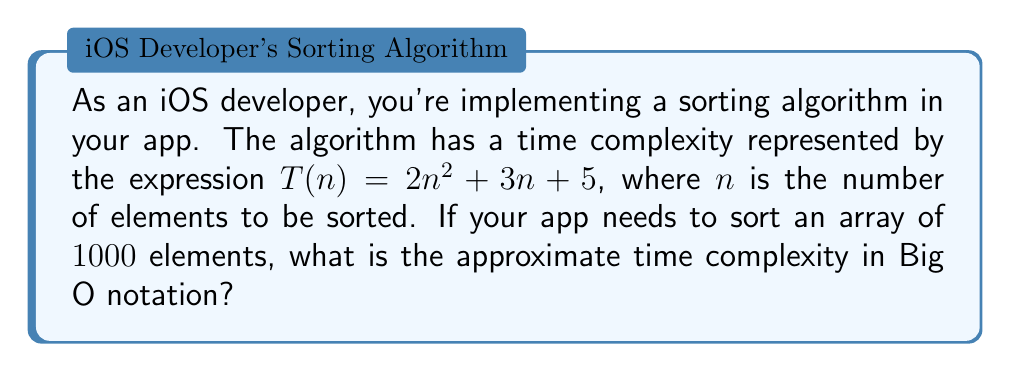Provide a solution to this math problem. To determine the time complexity in Big O notation, we need to identify the most significant term in the given expression as $n$ approaches infinity. Let's break down the process:

1. Given time complexity expression: $T(n) = 2n^2 + 3n + 5$

2. Analyze each term:
   - $2n^2$ grows quadratically
   - $3n$ grows linearly
   - $5$ is constant

3. As $n$ increases, the $2n^2$ term dominates the others:
   $\lim_{n \to \infty} \frac{2n^2}{3n} = \infty$
   $\lim_{n \to \infty} \frac{2n^2}{5} = \infty$

4. In Big O notation, we ignore coefficients and lower-order terms:
   $T(n) = O(n^2)$

5. For $n = 1000$:
   $T(1000) = 2(1000)^2 + 3(1000) + 5$
   $= 2,000,000 + 3,000 + 5$
   $= 2,003,005$

The dominant term $2,000,000$ comes from $2n^2$, confirming that $O(n^2)$ is the correct time complexity.
Answer: $O(n^2)$ 